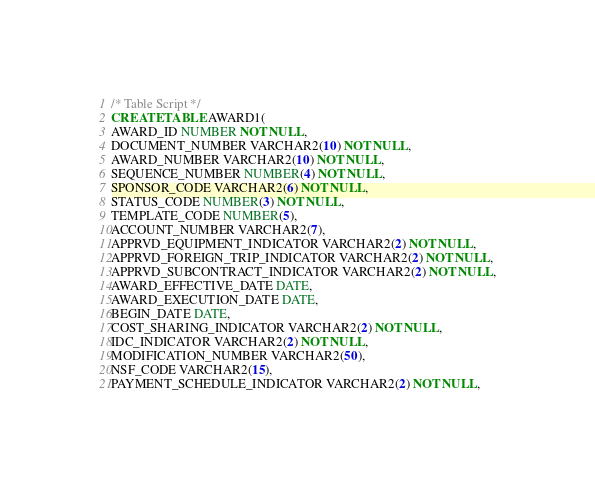<code> <loc_0><loc_0><loc_500><loc_500><_SQL_>/* Table Script */ 
CREATE TABLE AWARD1(
AWARD_ID NUMBER NOT NULL,
DOCUMENT_NUMBER VARCHAR2(10) NOT NULL,
AWARD_NUMBER VARCHAR2(10) NOT NULL,
SEQUENCE_NUMBER NUMBER(4) NOT NULL,
SPONSOR_CODE VARCHAR2(6) NOT NULL,
STATUS_CODE NUMBER(3) NOT NULL,
TEMPLATE_CODE NUMBER(5),
ACCOUNT_NUMBER VARCHAR2(7),
APPRVD_EQUIPMENT_INDICATOR VARCHAR2(2) NOT NULL,
APPRVD_FOREIGN_TRIP_INDICATOR VARCHAR2(2) NOT NULL,
APPRVD_SUBCONTRACT_INDICATOR VARCHAR2(2) NOT NULL,
AWARD_EFFECTIVE_DATE DATE,
AWARD_EXECUTION_DATE DATE,
BEGIN_DATE DATE,
COST_SHARING_INDICATOR VARCHAR2(2) NOT NULL,
IDC_INDICATOR VARCHAR2(2) NOT NULL,
MODIFICATION_NUMBER VARCHAR2(50),
NSF_CODE VARCHAR2(15),
PAYMENT_SCHEDULE_INDICATOR VARCHAR2(2) NOT NULL,</code> 